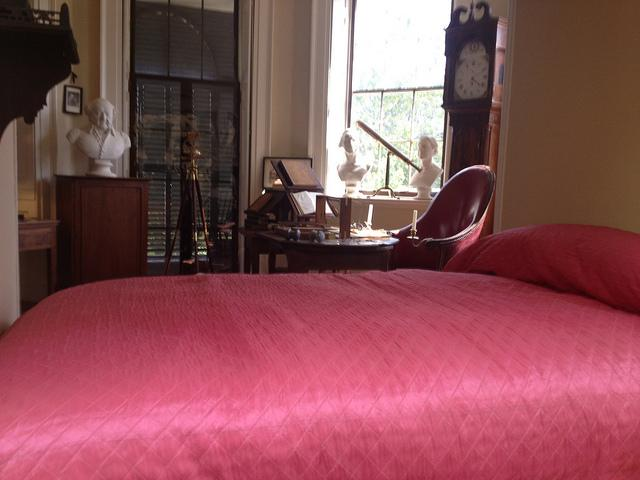What category of clocks does the clock by the window belong to? Please explain your reasoning. longcase. Longcase clocks are large clocks in tall slender wooden cabinets. 